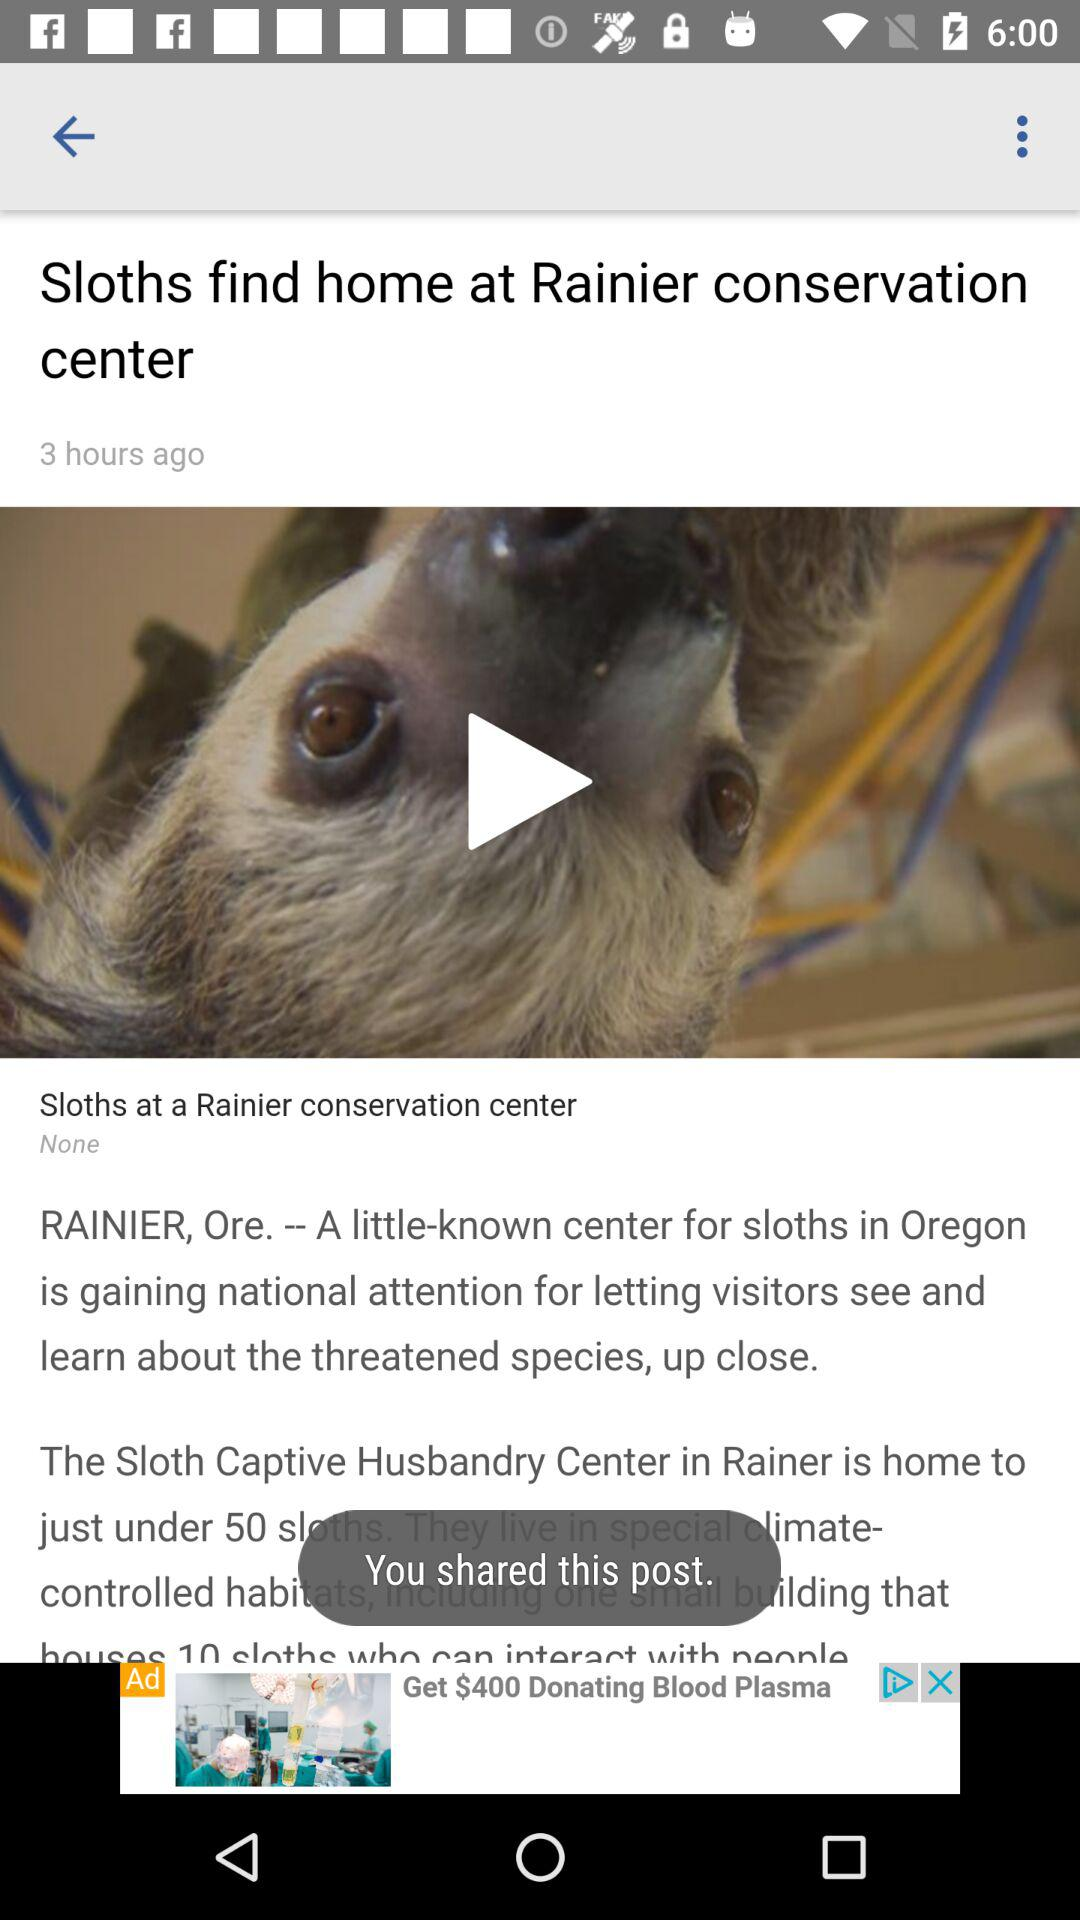What is the name of the center? The name of the center is "Rainier conservation center". 